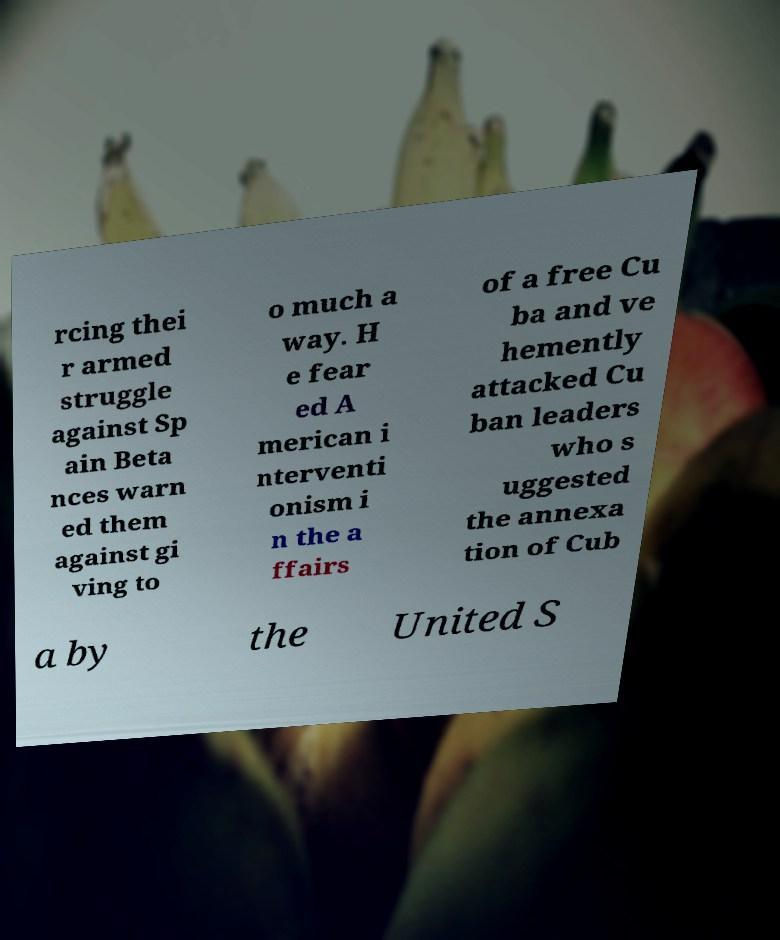Please read and relay the text visible in this image. What does it say? rcing thei r armed struggle against Sp ain Beta nces warn ed them against gi ving to o much a way. H e fear ed A merican i nterventi onism i n the a ffairs of a free Cu ba and ve hemently attacked Cu ban leaders who s uggested the annexa tion of Cub a by the United S 